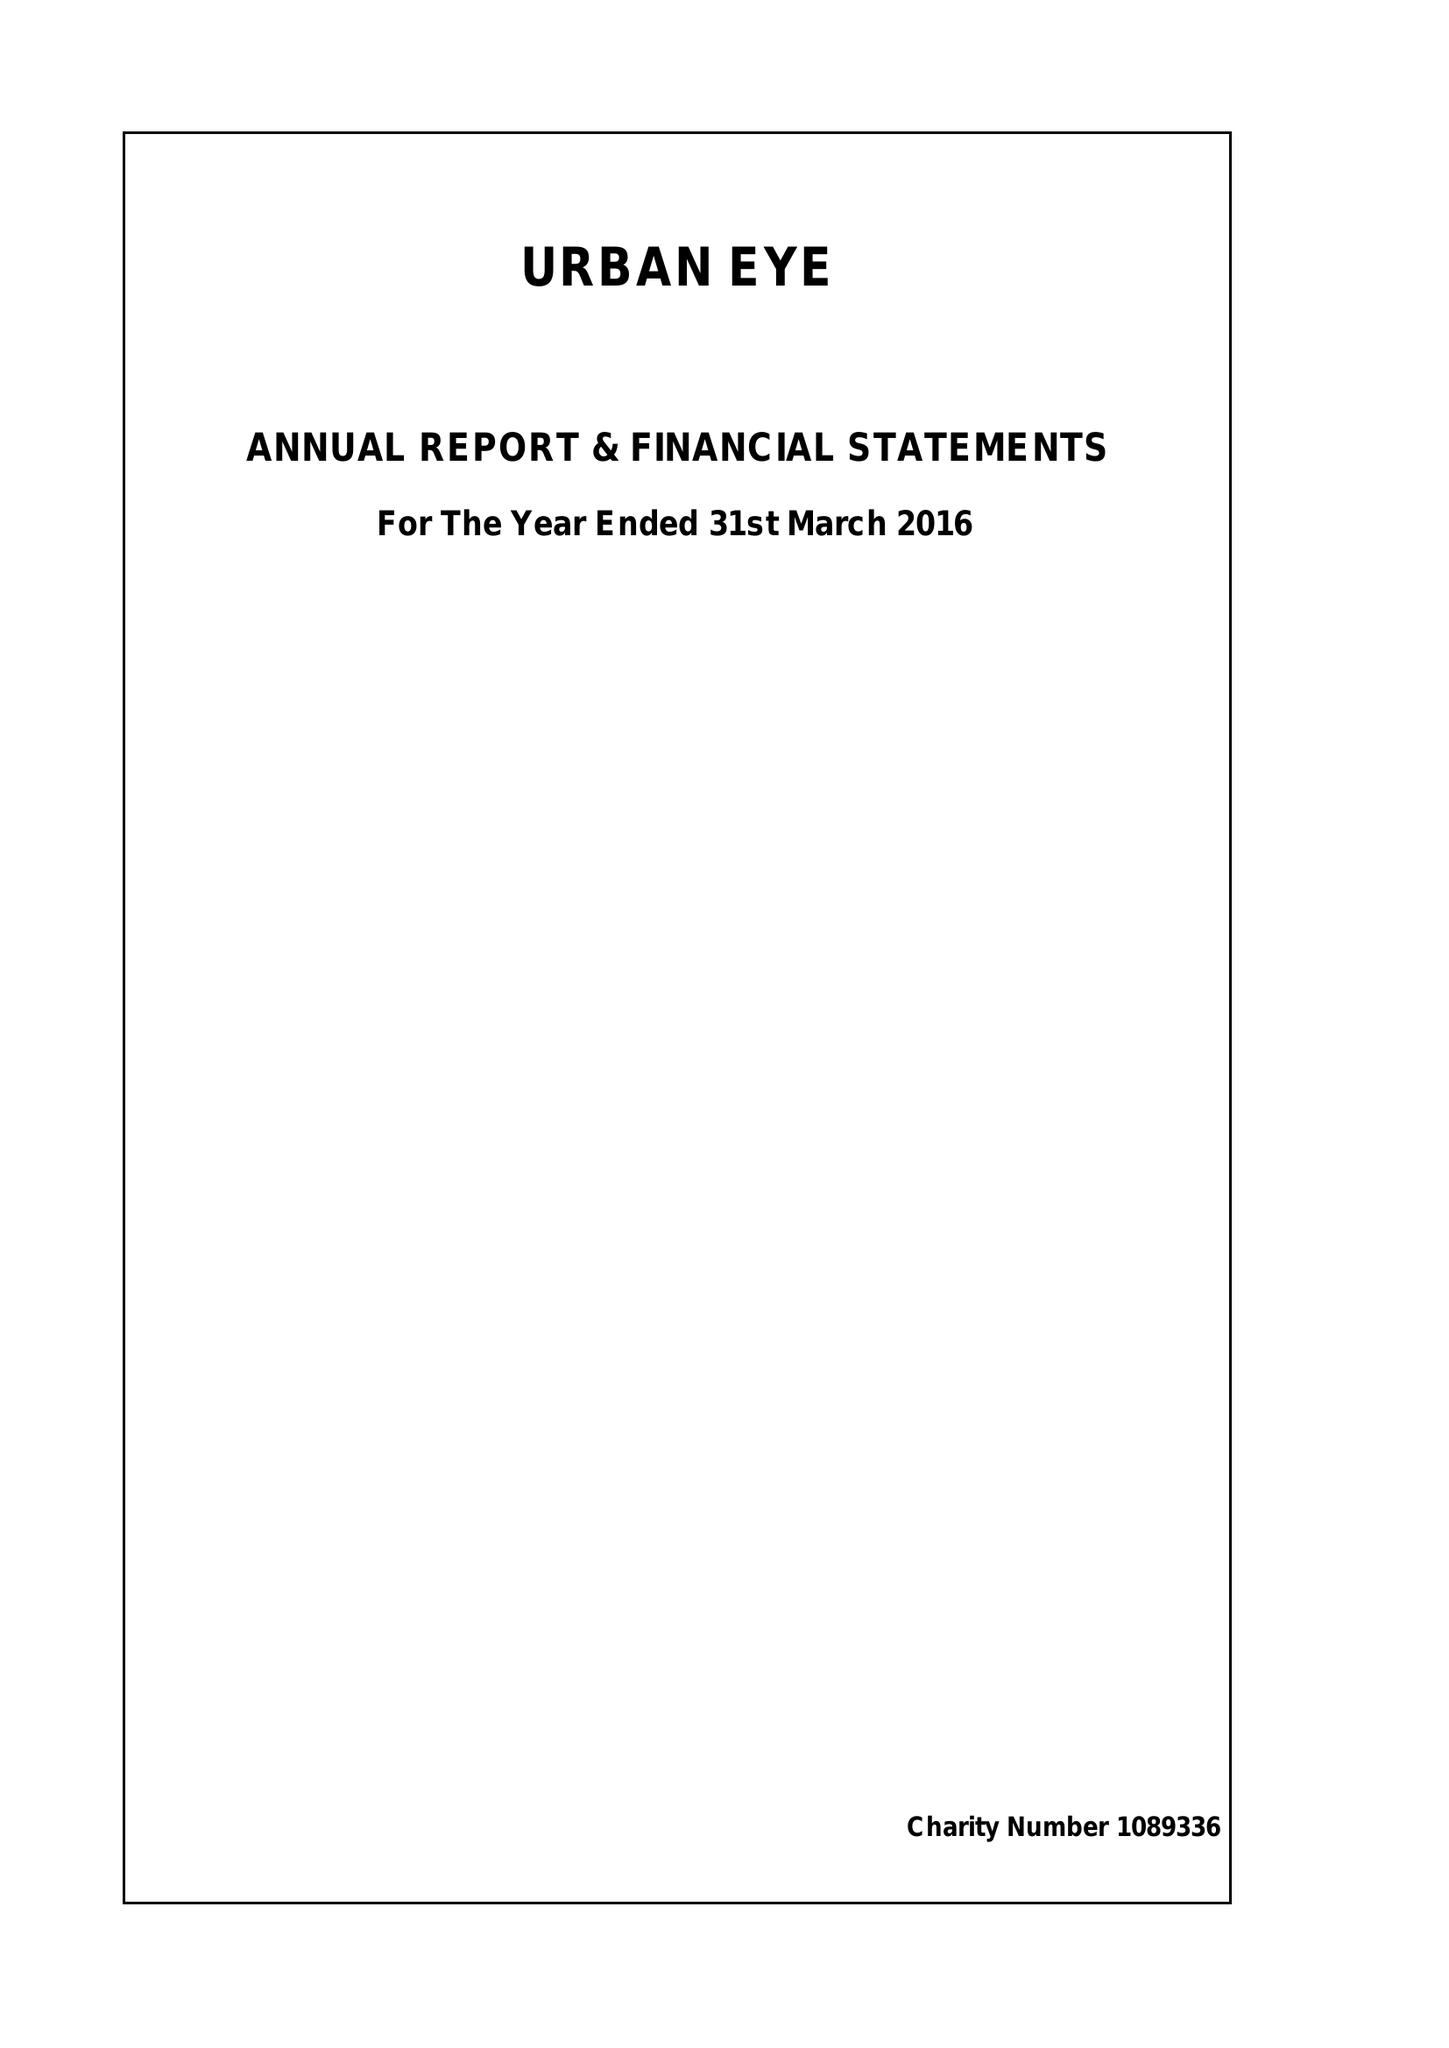What is the value for the address__street_line?
Answer the question using a single word or phrase. WHITCHURCH ROAD 